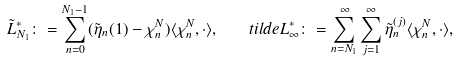Convert formula to latex. <formula><loc_0><loc_0><loc_500><loc_500>\tilde { L } ^ { * } _ { N _ { 1 } } \colon = \sum _ { n = 0 } ^ { N _ { 1 } - 1 } ( \tilde { \eta } _ { n } ( 1 ) - \chi _ { n } ^ { N } ) \langle \chi _ { n } ^ { N } , \cdot \rangle , \quad t i l d e { L } ^ { * } _ { \infty } \colon = \sum _ { n = N _ { 1 } } ^ { \infty } \sum _ { j = 1 } ^ { \infty } \tilde { \eta } _ { n } ^ { ( j ) } \langle \chi _ { n } ^ { N } , \cdot \rangle ,</formula> 